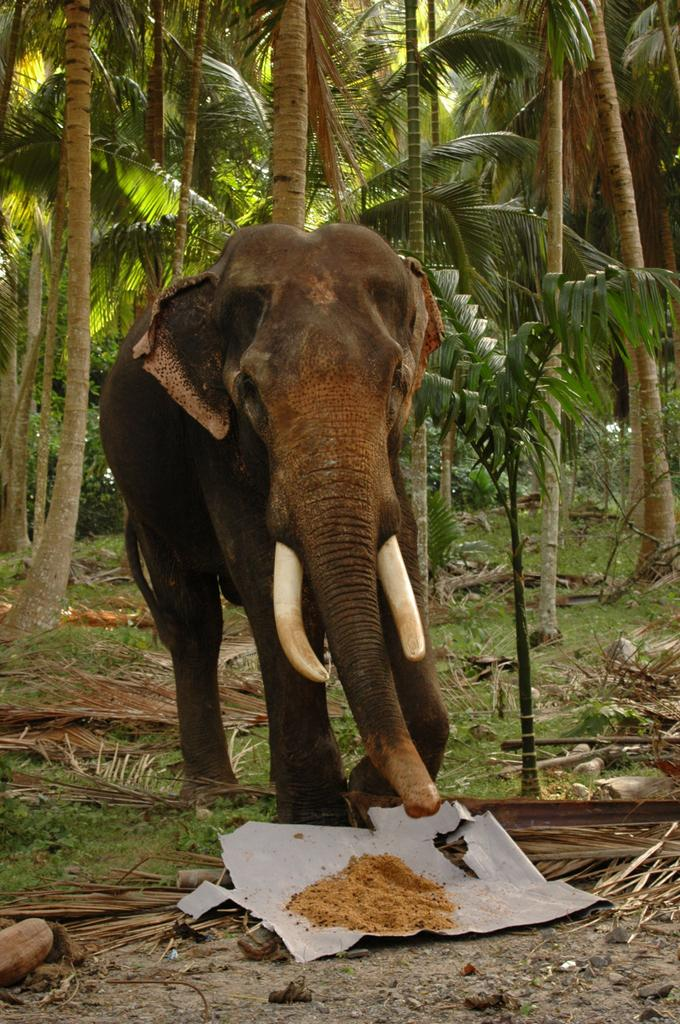What animal is present in the image? There is an elephant in the image. What is the elephant doing in the image? The elephant is walking on the ground. What can be seen on the ground besides the elephant? There are cut down branches and powder on a paper on the ground. What can be seen in the background of the image? There are trees and plants in the background of the image. What type of quilt is being used to cover the elephant in the image? There is no quilt present in the image; the elephant is walking on the ground. What color is the dress worn by the elephant in the image? There is no dress worn by the elephant in the image; it is an elephant, not a person. 